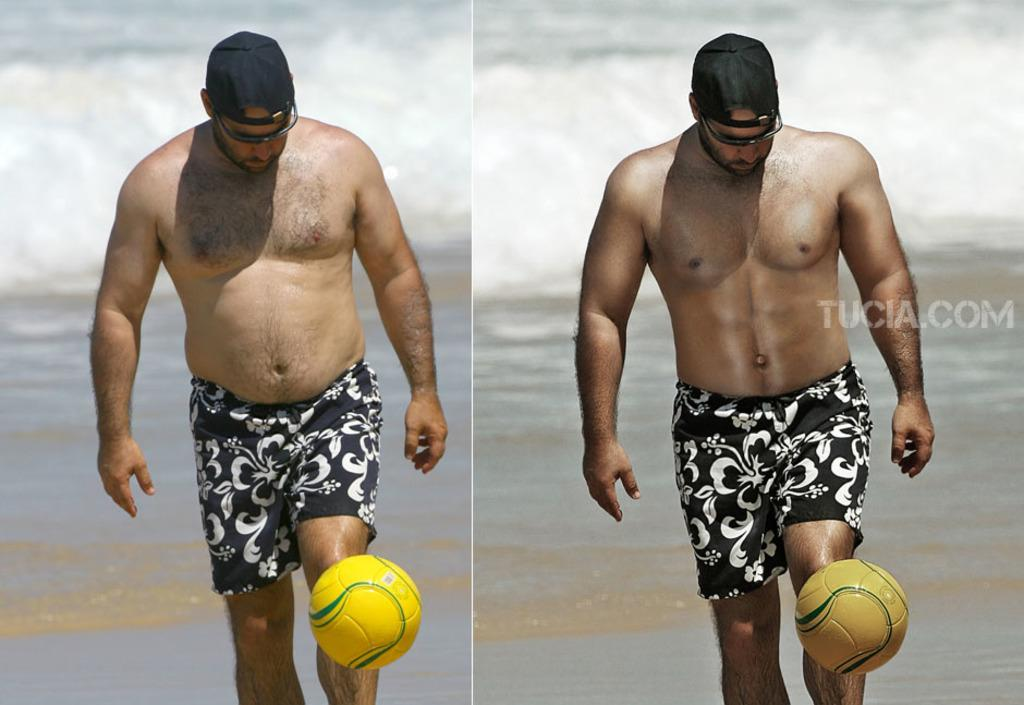Who is present in the image? There is a person in the image. What is the setting of the image? The person is in a beach setting. What is the person wearing? The person is wearing a short, a cap, and spectacles. What activity is the person engaged in? The person is playing with a ball. What type of instrument is the person playing in the image? There is no instrument present in the image; the person is playing with a ball. Can you describe the cave in the image? There is no cave present in the image; the person is in a beach setting. 